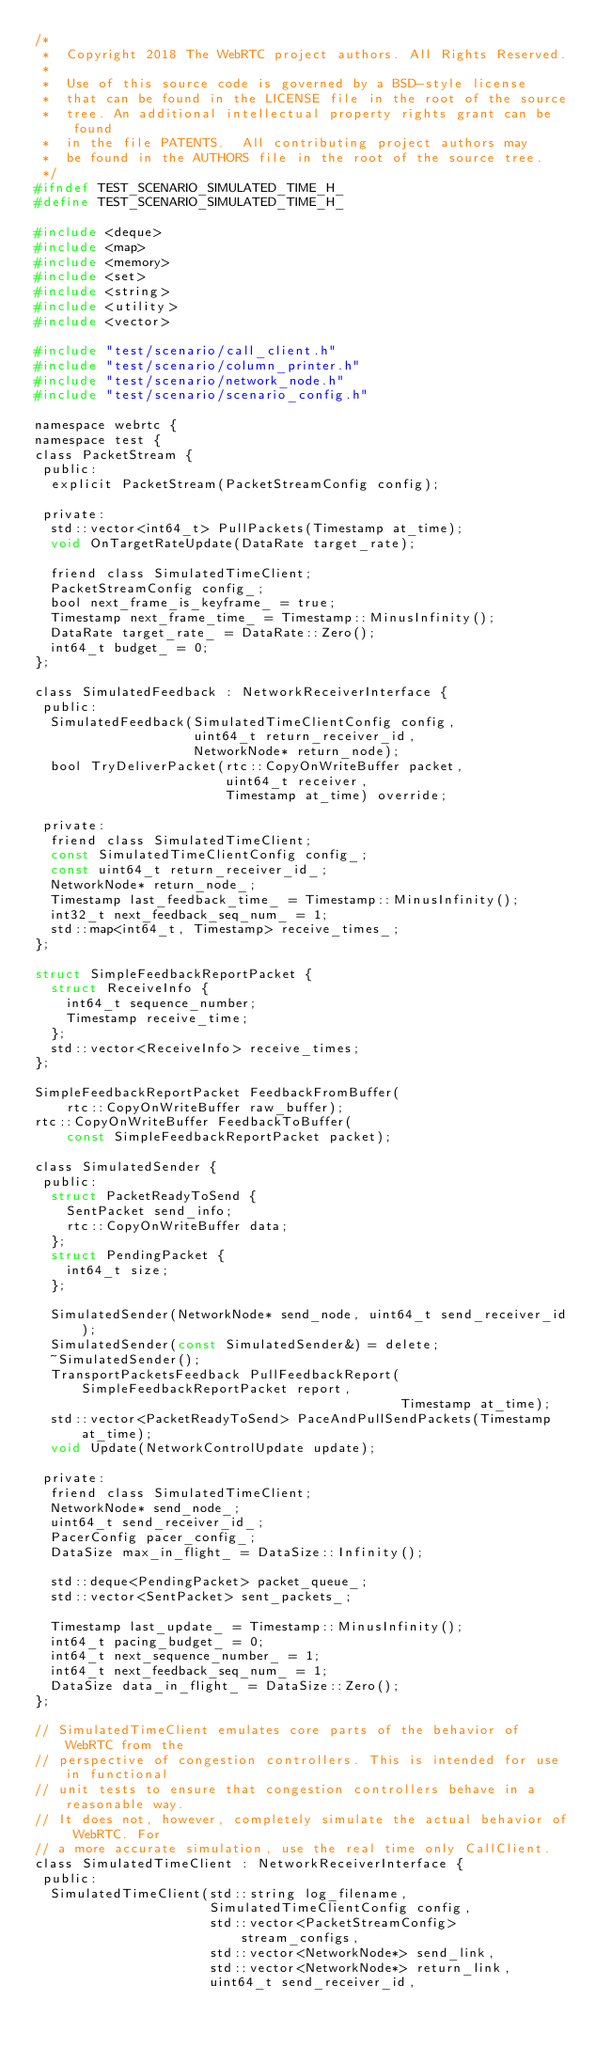<code> <loc_0><loc_0><loc_500><loc_500><_C_>/*
 *  Copyright 2018 The WebRTC project authors. All Rights Reserved.
 *
 *  Use of this source code is governed by a BSD-style license
 *  that can be found in the LICENSE file in the root of the source
 *  tree. An additional intellectual property rights grant can be found
 *  in the file PATENTS.  All contributing project authors may
 *  be found in the AUTHORS file in the root of the source tree.
 */
#ifndef TEST_SCENARIO_SIMULATED_TIME_H_
#define TEST_SCENARIO_SIMULATED_TIME_H_

#include <deque>
#include <map>
#include <memory>
#include <set>
#include <string>
#include <utility>
#include <vector>

#include "test/scenario/call_client.h"
#include "test/scenario/column_printer.h"
#include "test/scenario/network_node.h"
#include "test/scenario/scenario_config.h"

namespace webrtc {
namespace test {
class PacketStream {
 public:
  explicit PacketStream(PacketStreamConfig config);

 private:
  std::vector<int64_t> PullPackets(Timestamp at_time);
  void OnTargetRateUpdate(DataRate target_rate);

  friend class SimulatedTimeClient;
  PacketStreamConfig config_;
  bool next_frame_is_keyframe_ = true;
  Timestamp next_frame_time_ = Timestamp::MinusInfinity();
  DataRate target_rate_ = DataRate::Zero();
  int64_t budget_ = 0;
};

class SimulatedFeedback : NetworkReceiverInterface {
 public:
  SimulatedFeedback(SimulatedTimeClientConfig config,
                    uint64_t return_receiver_id,
                    NetworkNode* return_node);
  bool TryDeliverPacket(rtc::CopyOnWriteBuffer packet,
                        uint64_t receiver,
                        Timestamp at_time) override;

 private:
  friend class SimulatedTimeClient;
  const SimulatedTimeClientConfig config_;
  const uint64_t return_receiver_id_;
  NetworkNode* return_node_;
  Timestamp last_feedback_time_ = Timestamp::MinusInfinity();
  int32_t next_feedback_seq_num_ = 1;
  std::map<int64_t, Timestamp> receive_times_;
};

struct SimpleFeedbackReportPacket {
  struct ReceiveInfo {
    int64_t sequence_number;
    Timestamp receive_time;
  };
  std::vector<ReceiveInfo> receive_times;
};

SimpleFeedbackReportPacket FeedbackFromBuffer(
    rtc::CopyOnWriteBuffer raw_buffer);
rtc::CopyOnWriteBuffer FeedbackToBuffer(
    const SimpleFeedbackReportPacket packet);

class SimulatedSender {
 public:
  struct PacketReadyToSend {
    SentPacket send_info;
    rtc::CopyOnWriteBuffer data;
  };
  struct PendingPacket {
    int64_t size;
  };

  SimulatedSender(NetworkNode* send_node, uint64_t send_receiver_id);
  SimulatedSender(const SimulatedSender&) = delete;
  ~SimulatedSender();
  TransportPacketsFeedback PullFeedbackReport(SimpleFeedbackReportPacket report,
                                              Timestamp at_time);
  std::vector<PacketReadyToSend> PaceAndPullSendPackets(Timestamp at_time);
  void Update(NetworkControlUpdate update);

 private:
  friend class SimulatedTimeClient;
  NetworkNode* send_node_;
  uint64_t send_receiver_id_;
  PacerConfig pacer_config_;
  DataSize max_in_flight_ = DataSize::Infinity();

  std::deque<PendingPacket> packet_queue_;
  std::vector<SentPacket> sent_packets_;

  Timestamp last_update_ = Timestamp::MinusInfinity();
  int64_t pacing_budget_ = 0;
  int64_t next_sequence_number_ = 1;
  int64_t next_feedback_seq_num_ = 1;
  DataSize data_in_flight_ = DataSize::Zero();
};

// SimulatedTimeClient emulates core parts of the behavior of WebRTC from the
// perspective of congestion controllers. This is intended for use in functional
// unit tests to ensure that congestion controllers behave in a reasonable way.
// It does not, however, completely simulate the actual behavior of WebRTC. For
// a more accurate simulation, use the real time only CallClient.
class SimulatedTimeClient : NetworkReceiverInterface {
 public:
  SimulatedTimeClient(std::string log_filename,
                      SimulatedTimeClientConfig config,
                      std::vector<PacketStreamConfig> stream_configs,
                      std::vector<NetworkNode*> send_link,
                      std::vector<NetworkNode*> return_link,
                      uint64_t send_receiver_id,</code> 